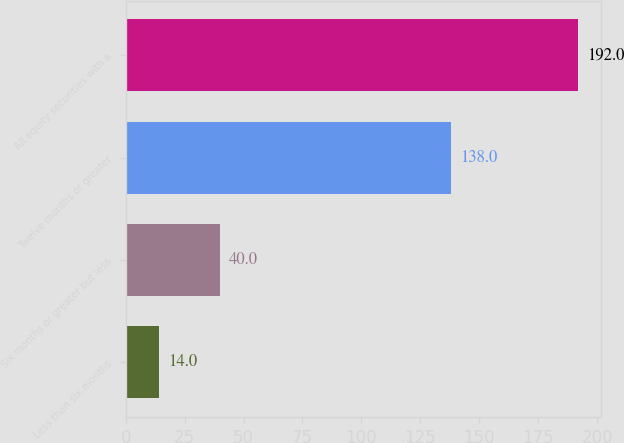<chart> <loc_0><loc_0><loc_500><loc_500><bar_chart><fcel>Less than six months<fcel>Six months or greater but less<fcel>Twelve months or greater<fcel>All equity securities with a<nl><fcel>14<fcel>40<fcel>138<fcel>192<nl></chart> 